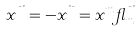Convert formula to latex. <formula><loc_0><loc_0><loc_500><loc_500>x ^ { \mu \nu } = - x ^ { \nu \mu } = x ^ { m } \gamma ^ { \mu \nu } _ { m }</formula> 